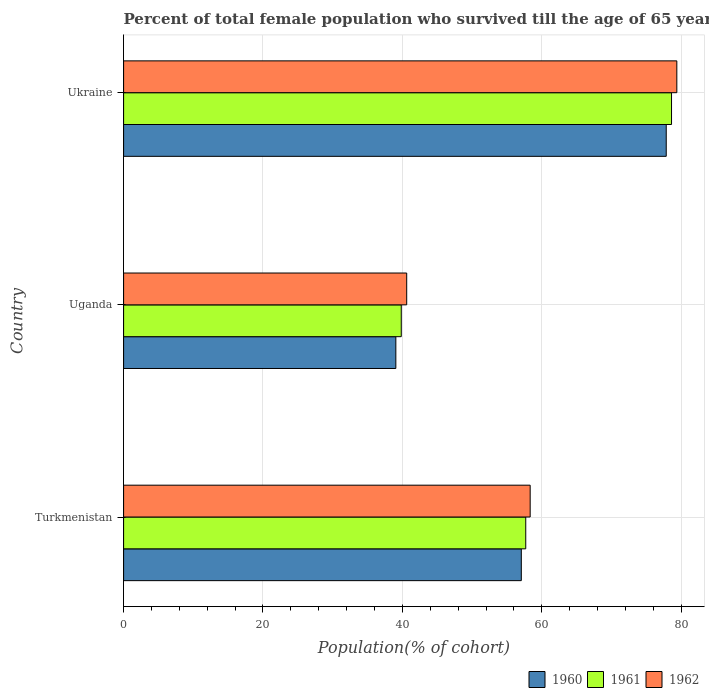How many groups of bars are there?
Give a very brief answer. 3. How many bars are there on the 1st tick from the top?
Ensure brevity in your answer.  3. How many bars are there on the 1st tick from the bottom?
Provide a short and direct response. 3. What is the label of the 1st group of bars from the top?
Your answer should be very brief. Ukraine. In how many cases, is the number of bars for a given country not equal to the number of legend labels?
Give a very brief answer. 0. What is the percentage of total female population who survived till the age of 65 years in 1961 in Turkmenistan?
Your response must be concise. 57.7. Across all countries, what is the maximum percentage of total female population who survived till the age of 65 years in 1960?
Your answer should be very brief. 77.85. Across all countries, what is the minimum percentage of total female population who survived till the age of 65 years in 1962?
Your response must be concise. 40.62. In which country was the percentage of total female population who survived till the age of 65 years in 1962 maximum?
Give a very brief answer. Ukraine. In which country was the percentage of total female population who survived till the age of 65 years in 1961 minimum?
Give a very brief answer. Uganda. What is the total percentage of total female population who survived till the age of 65 years in 1960 in the graph?
Your response must be concise. 173.98. What is the difference between the percentage of total female population who survived till the age of 65 years in 1960 in Turkmenistan and that in Ukraine?
Provide a succinct answer. -20.79. What is the difference between the percentage of total female population who survived till the age of 65 years in 1961 in Uganda and the percentage of total female population who survived till the age of 65 years in 1960 in Turkmenistan?
Your answer should be very brief. -17.22. What is the average percentage of total female population who survived till the age of 65 years in 1961 per country?
Keep it short and to the point. 58.72. What is the difference between the percentage of total female population who survived till the age of 65 years in 1962 and percentage of total female population who survived till the age of 65 years in 1960 in Turkmenistan?
Give a very brief answer. 1.27. In how many countries, is the percentage of total female population who survived till the age of 65 years in 1960 greater than 48 %?
Make the answer very short. 2. What is the ratio of the percentage of total female population who survived till the age of 65 years in 1962 in Turkmenistan to that in Ukraine?
Your answer should be compact. 0.73. What is the difference between the highest and the second highest percentage of total female population who survived till the age of 65 years in 1961?
Your response must be concise. 20.92. What is the difference between the highest and the lowest percentage of total female population who survived till the age of 65 years in 1961?
Your answer should be compact. 38.77. Is the sum of the percentage of total female population who survived till the age of 65 years in 1962 in Turkmenistan and Ukraine greater than the maximum percentage of total female population who survived till the age of 65 years in 1960 across all countries?
Offer a terse response. Yes. What does the 3rd bar from the bottom in Uganda represents?
Give a very brief answer. 1962. Is it the case that in every country, the sum of the percentage of total female population who survived till the age of 65 years in 1961 and percentage of total female population who survived till the age of 65 years in 1960 is greater than the percentage of total female population who survived till the age of 65 years in 1962?
Provide a succinct answer. Yes. Are all the bars in the graph horizontal?
Your response must be concise. Yes. How many countries are there in the graph?
Give a very brief answer. 3. Are the values on the major ticks of X-axis written in scientific E-notation?
Your response must be concise. No. Does the graph contain any zero values?
Provide a short and direct response. No. Does the graph contain grids?
Ensure brevity in your answer.  Yes. How many legend labels are there?
Provide a short and direct response. 3. How are the legend labels stacked?
Your answer should be very brief. Horizontal. What is the title of the graph?
Give a very brief answer. Percent of total female population who survived till the age of 65 years. Does "1997" appear as one of the legend labels in the graph?
Give a very brief answer. No. What is the label or title of the X-axis?
Make the answer very short. Population(% of cohort). What is the label or title of the Y-axis?
Provide a succinct answer. Country. What is the Population(% of cohort) in 1960 in Turkmenistan?
Keep it short and to the point. 57.06. What is the Population(% of cohort) in 1961 in Turkmenistan?
Ensure brevity in your answer.  57.7. What is the Population(% of cohort) of 1962 in Turkmenistan?
Give a very brief answer. 58.33. What is the Population(% of cohort) of 1960 in Uganda?
Give a very brief answer. 39.06. What is the Population(% of cohort) in 1961 in Uganda?
Provide a succinct answer. 39.84. What is the Population(% of cohort) of 1962 in Uganda?
Ensure brevity in your answer.  40.62. What is the Population(% of cohort) of 1960 in Ukraine?
Offer a very short reply. 77.85. What is the Population(% of cohort) of 1961 in Ukraine?
Make the answer very short. 78.61. What is the Population(% of cohort) in 1962 in Ukraine?
Make the answer very short. 79.37. Across all countries, what is the maximum Population(% of cohort) in 1960?
Offer a very short reply. 77.85. Across all countries, what is the maximum Population(% of cohort) of 1961?
Give a very brief answer. 78.61. Across all countries, what is the maximum Population(% of cohort) in 1962?
Offer a very short reply. 79.37. Across all countries, what is the minimum Population(% of cohort) of 1960?
Your answer should be very brief. 39.06. Across all countries, what is the minimum Population(% of cohort) of 1961?
Ensure brevity in your answer.  39.84. Across all countries, what is the minimum Population(% of cohort) of 1962?
Offer a terse response. 40.62. What is the total Population(% of cohort) in 1960 in the graph?
Make the answer very short. 173.98. What is the total Population(% of cohort) in 1961 in the graph?
Your answer should be compact. 176.15. What is the total Population(% of cohort) in 1962 in the graph?
Offer a very short reply. 178.32. What is the difference between the Population(% of cohort) in 1960 in Turkmenistan and that in Uganda?
Offer a terse response. 18. What is the difference between the Population(% of cohort) of 1961 in Turkmenistan and that in Uganda?
Offer a terse response. 17.86. What is the difference between the Population(% of cohort) of 1962 in Turkmenistan and that in Uganda?
Your response must be concise. 17.71. What is the difference between the Population(% of cohort) of 1960 in Turkmenistan and that in Ukraine?
Offer a very short reply. -20.79. What is the difference between the Population(% of cohort) in 1961 in Turkmenistan and that in Ukraine?
Provide a succinct answer. -20.92. What is the difference between the Population(% of cohort) in 1962 in Turkmenistan and that in Ukraine?
Provide a succinct answer. -21.04. What is the difference between the Population(% of cohort) in 1960 in Uganda and that in Ukraine?
Provide a succinct answer. -38.79. What is the difference between the Population(% of cohort) in 1961 in Uganda and that in Ukraine?
Provide a short and direct response. -38.77. What is the difference between the Population(% of cohort) in 1962 in Uganda and that in Ukraine?
Your response must be concise. -38.76. What is the difference between the Population(% of cohort) in 1960 in Turkmenistan and the Population(% of cohort) in 1961 in Uganda?
Offer a very short reply. 17.22. What is the difference between the Population(% of cohort) of 1960 in Turkmenistan and the Population(% of cohort) of 1962 in Uganda?
Offer a very short reply. 16.44. What is the difference between the Population(% of cohort) of 1961 in Turkmenistan and the Population(% of cohort) of 1962 in Uganda?
Give a very brief answer. 17.08. What is the difference between the Population(% of cohort) in 1960 in Turkmenistan and the Population(% of cohort) in 1961 in Ukraine?
Ensure brevity in your answer.  -21.55. What is the difference between the Population(% of cohort) in 1960 in Turkmenistan and the Population(% of cohort) in 1962 in Ukraine?
Keep it short and to the point. -22.31. What is the difference between the Population(% of cohort) of 1961 in Turkmenistan and the Population(% of cohort) of 1962 in Ukraine?
Offer a very short reply. -21.68. What is the difference between the Population(% of cohort) of 1960 in Uganda and the Population(% of cohort) of 1961 in Ukraine?
Your answer should be very brief. -39.55. What is the difference between the Population(% of cohort) of 1960 in Uganda and the Population(% of cohort) of 1962 in Ukraine?
Provide a short and direct response. -40.31. What is the difference between the Population(% of cohort) of 1961 in Uganda and the Population(% of cohort) of 1962 in Ukraine?
Provide a short and direct response. -39.53. What is the average Population(% of cohort) of 1960 per country?
Make the answer very short. 57.99. What is the average Population(% of cohort) of 1961 per country?
Provide a succinct answer. 58.72. What is the average Population(% of cohort) in 1962 per country?
Provide a succinct answer. 59.44. What is the difference between the Population(% of cohort) in 1960 and Population(% of cohort) in 1961 in Turkmenistan?
Provide a succinct answer. -0.64. What is the difference between the Population(% of cohort) of 1960 and Population(% of cohort) of 1962 in Turkmenistan?
Provide a short and direct response. -1.27. What is the difference between the Population(% of cohort) in 1961 and Population(% of cohort) in 1962 in Turkmenistan?
Offer a very short reply. -0.64. What is the difference between the Population(% of cohort) of 1960 and Population(% of cohort) of 1961 in Uganda?
Offer a terse response. -0.78. What is the difference between the Population(% of cohort) in 1960 and Population(% of cohort) in 1962 in Uganda?
Offer a terse response. -1.56. What is the difference between the Population(% of cohort) in 1961 and Population(% of cohort) in 1962 in Uganda?
Keep it short and to the point. -0.78. What is the difference between the Population(% of cohort) of 1960 and Population(% of cohort) of 1961 in Ukraine?
Give a very brief answer. -0.76. What is the difference between the Population(% of cohort) of 1960 and Population(% of cohort) of 1962 in Ukraine?
Offer a terse response. -1.52. What is the difference between the Population(% of cohort) of 1961 and Population(% of cohort) of 1962 in Ukraine?
Make the answer very short. -0.76. What is the ratio of the Population(% of cohort) of 1960 in Turkmenistan to that in Uganda?
Make the answer very short. 1.46. What is the ratio of the Population(% of cohort) in 1961 in Turkmenistan to that in Uganda?
Your answer should be very brief. 1.45. What is the ratio of the Population(% of cohort) of 1962 in Turkmenistan to that in Uganda?
Offer a very short reply. 1.44. What is the ratio of the Population(% of cohort) in 1960 in Turkmenistan to that in Ukraine?
Offer a terse response. 0.73. What is the ratio of the Population(% of cohort) in 1961 in Turkmenistan to that in Ukraine?
Make the answer very short. 0.73. What is the ratio of the Population(% of cohort) of 1962 in Turkmenistan to that in Ukraine?
Give a very brief answer. 0.73. What is the ratio of the Population(% of cohort) in 1960 in Uganda to that in Ukraine?
Provide a short and direct response. 0.5. What is the ratio of the Population(% of cohort) in 1961 in Uganda to that in Ukraine?
Make the answer very short. 0.51. What is the ratio of the Population(% of cohort) of 1962 in Uganda to that in Ukraine?
Offer a terse response. 0.51. What is the difference between the highest and the second highest Population(% of cohort) of 1960?
Your response must be concise. 20.79. What is the difference between the highest and the second highest Population(% of cohort) of 1961?
Ensure brevity in your answer.  20.92. What is the difference between the highest and the second highest Population(% of cohort) in 1962?
Give a very brief answer. 21.04. What is the difference between the highest and the lowest Population(% of cohort) in 1960?
Keep it short and to the point. 38.79. What is the difference between the highest and the lowest Population(% of cohort) of 1961?
Offer a very short reply. 38.77. What is the difference between the highest and the lowest Population(% of cohort) in 1962?
Your response must be concise. 38.76. 